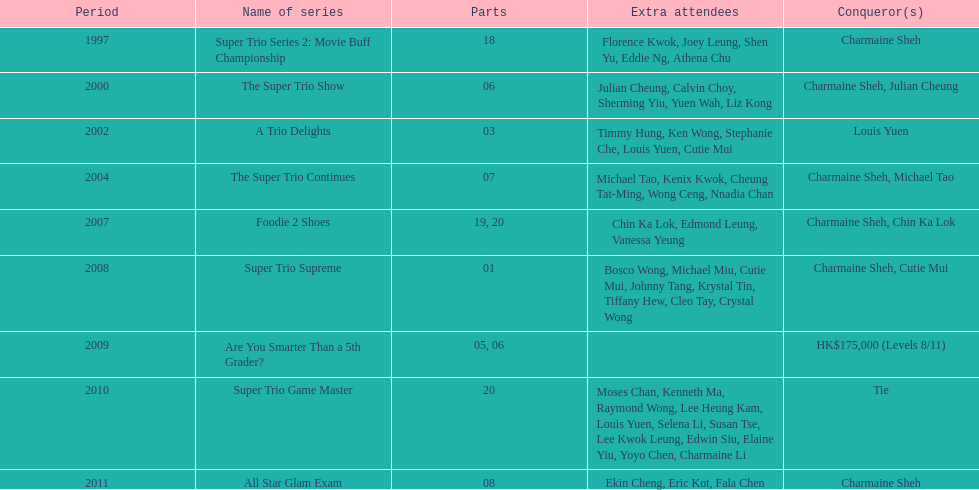What year was the only year were a tie occurred? 2010. 